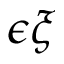Convert formula to latex. <formula><loc_0><loc_0><loc_500><loc_500>\epsilon \xi</formula> 